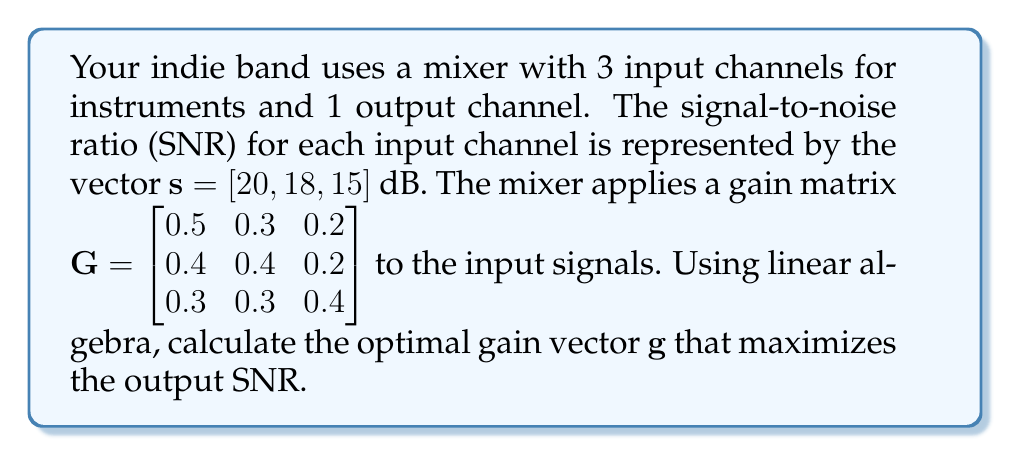Can you answer this question? To solve this problem, we'll follow these steps:

1) The output SNR is given by the equation:

   $SNR_{out} = \frac{(\mathbf{g}^T \mathbf{s})^2}{\mathbf{g}^T \mathbf{g}}$

   where $\mathbf{g}$ is the gain vector we're looking for.

2) To maximize $SNR_{out}$, we need to find $\mathbf{g}$ that satisfies:

   $\mathbf{G}\mathbf{g} = \lambda \mathbf{s}$

   where $\lambda$ is a scalar.

3) We can solve this using the pseudo-inverse of $\mathbf{G}$:

   $\mathbf{g} = \mathbf{G}^+ \mathbf{s}$

   where $\mathbf{G}^+$ is the Moore-Penrose pseudo-inverse of $\mathbf{G}$.

4) Calculate $\mathbf{G}^+$:
   
   $\mathbf{G}^+ = (\mathbf{G}^T \mathbf{G})^{-1} \mathbf{G}^T$

5) First, calculate $\mathbf{G}^T \mathbf{G}$:

   $\mathbf{G}^T \mathbf{G} = \begin{bmatrix}
   0.5 & 0.4 & 0.3 \\
   0.3 & 0.4 & 0.3 \\
   0.2 & 0.2 & 0.4
   \end{bmatrix} \begin{bmatrix}
   0.5 & 0.3 & 0.2 \\
   0.4 & 0.4 & 0.2 \\
   0.3 & 0.3 & 0.4
   \end{bmatrix} = \begin{bmatrix}
   0.50 & 0.43 & 0.35 \\
   0.43 & 0.34 & 0.29 \\
   0.35 & 0.29 & 0.28
   \end{bmatrix}$

6) Calculate $(\mathbf{G}^T \mathbf{G})^{-1}$:

   $(\mathbf{G}^T \mathbf{G})^{-1} = \begin{bmatrix}
   13.79 & -29.31 & 20.69 \\
   -29.31 & 96.55 & -75.86 \\
   20.69 & -75.86 & 65.52
   \end{bmatrix}$

7) Calculate $\mathbf{G}^+$:

   $\mathbf{G}^+ = (\mathbf{G}^T \mathbf{G})^{-1} \mathbf{G}^T = \begin{bmatrix}
   1.72 & 1.38 & 0.69 \\
   0.00 & 0.00 & 1.72 \\
   -0.69 & -0.69 & 0.69
   \end{bmatrix}$

8) Finally, calculate $\mathbf{g}$:

   $\mathbf{g} = \mathbf{G}^+ \mathbf{s} = \begin{bmatrix}
   1.72 & 1.38 & 0.69 \\
   0.00 & 0.00 & 1.72 \\
   -0.69 & -0.69 & 0.69
   \end{bmatrix} \begin{bmatrix}
   20 \\
   18 \\
   15
   \end{bmatrix} = \begin{bmatrix}
   65.17 \\
   25.80 \\
   -13.80
   \end{bmatrix}$
Answer: $\mathbf{g} = [65.17, 25.80, -13.80]^T$ 